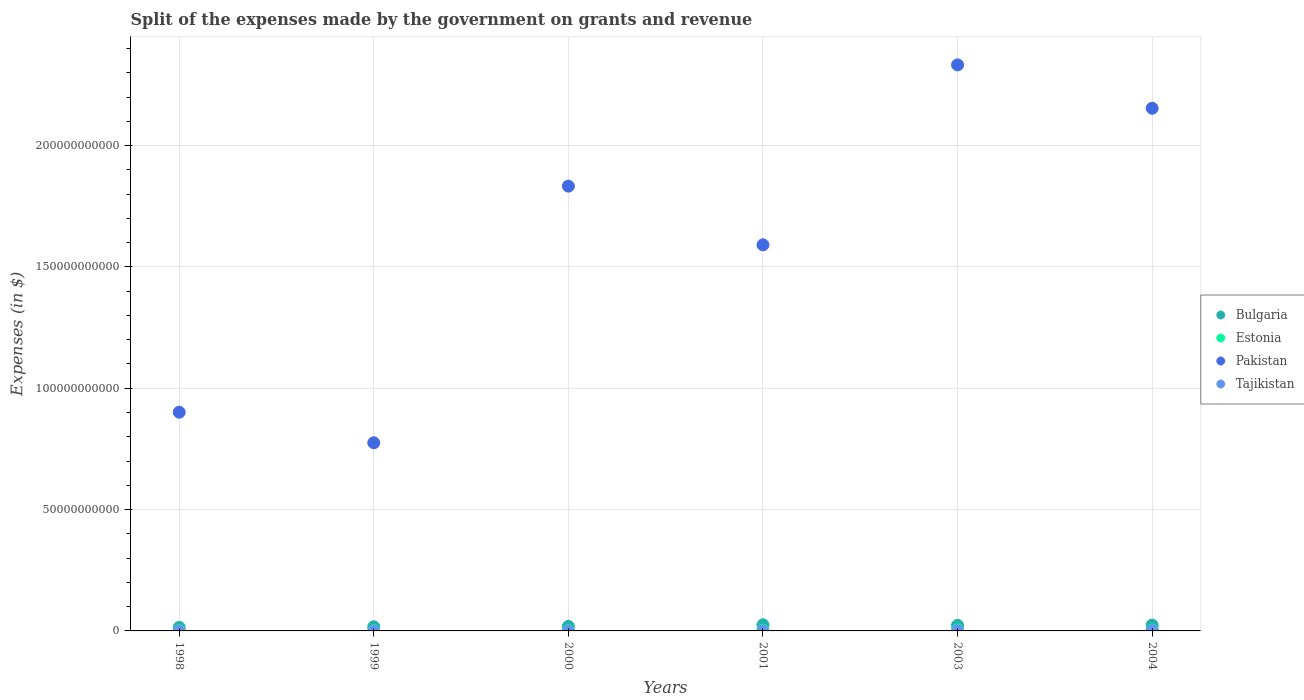How many different coloured dotlines are there?
Offer a terse response. 4. What is the expenses made by the government on grants and revenue in Pakistan in 2000?
Provide a short and direct response. 1.83e+11. Across all years, what is the maximum expenses made by the government on grants and revenue in Bulgaria?
Offer a very short reply. 2.52e+09. Across all years, what is the minimum expenses made by the government on grants and revenue in Tajikistan?
Offer a terse response. 5.25e+06. In which year was the expenses made by the government on grants and revenue in Pakistan maximum?
Offer a very short reply. 2003. What is the total expenses made by the government on grants and revenue in Tajikistan in the graph?
Offer a very short reply. 3.06e+08. What is the difference between the expenses made by the government on grants and revenue in Estonia in 1999 and that in 2000?
Offer a very short reply. -8.25e+07. What is the difference between the expenses made by the government on grants and revenue in Estonia in 1998 and the expenses made by the government on grants and revenue in Bulgaria in 1999?
Keep it short and to the point. -1.52e+09. What is the average expenses made by the government on grants and revenue in Tajikistan per year?
Your response must be concise. 5.10e+07. In the year 2004, what is the difference between the expenses made by the government on grants and revenue in Tajikistan and expenses made by the government on grants and revenue in Pakistan?
Give a very brief answer. -2.15e+11. In how many years, is the expenses made by the government on grants and revenue in Estonia greater than 120000000000 $?
Offer a terse response. 0. What is the ratio of the expenses made by the government on grants and revenue in Pakistan in 1998 to that in 2000?
Offer a very short reply. 0.49. Is the expenses made by the government on grants and revenue in Bulgaria in 2000 less than that in 2001?
Offer a very short reply. Yes. Is the difference between the expenses made by the government on grants and revenue in Tajikistan in 1999 and 2004 greater than the difference between the expenses made by the government on grants and revenue in Pakistan in 1999 and 2004?
Provide a succinct answer. Yes. What is the difference between the highest and the second highest expenses made by the government on grants and revenue in Bulgaria?
Make the answer very short. 1.20e+08. What is the difference between the highest and the lowest expenses made by the government on grants and revenue in Estonia?
Keep it short and to the point. 2.23e+08. In how many years, is the expenses made by the government on grants and revenue in Pakistan greater than the average expenses made by the government on grants and revenue in Pakistan taken over all years?
Make the answer very short. 3. Is the sum of the expenses made by the government on grants and revenue in Estonia in 1999 and 2001 greater than the maximum expenses made by the government on grants and revenue in Bulgaria across all years?
Your response must be concise. No. Is it the case that in every year, the sum of the expenses made by the government on grants and revenue in Tajikistan and expenses made by the government on grants and revenue in Bulgaria  is greater than the sum of expenses made by the government on grants and revenue in Pakistan and expenses made by the government on grants and revenue in Estonia?
Your response must be concise. No. Is it the case that in every year, the sum of the expenses made by the government on grants and revenue in Tajikistan and expenses made by the government on grants and revenue in Bulgaria  is greater than the expenses made by the government on grants and revenue in Estonia?
Provide a short and direct response. Yes. Does the expenses made by the government on grants and revenue in Pakistan monotonically increase over the years?
Keep it short and to the point. No. How many dotlines are there?
Give a very brief answer. 4. Does the graph contain grids?
Provide a short and direct response. Yes. Where does the legend appear in the graph?
Your response must be concise. Center right. What is the title of the graph?
Ensure brevity in your answer.  Split of the expenses made by the government on grants and revenue. Does "South Asia" appear as one of the legend labels in the graph?
Ensure brevity in your answer.  No. What is the label or title of the Y-axis?
Ensure brevity in your answer.  Expenses (in $). What is the Expenses (in $) of Bulgaria in 1998?
Your answer should be very brief. 1.45e+09. What is the Expenses (in $) of Estonia in 1998?
Your response must be concise. 1.80e+08. What is the Expenses (in $) in Pakistan in 1998?
Provide a short and direct response. 9.01e+1. What is the Expenses (in $) in Tajikistan in 1998?
Give a very brief answer. 5.25e+06. What is the Expenses (in $) of Bulgaria in 1999?
Offer a terse response. 1.70e+09. What is the Expenses (in $) of Estonia in 1999?
Your response must be concise. 1.80e+08. What is the Expenses (in $) of Pakistan in 1999?
Offer a very short reply. 7.75e+1. What is the Expenses (in $) of Tajikistan in 1999?
Make the answer very short. 6.30e+06. What is the Expenses (in $) in Bulgaria in 2000?
Provide a short and direct response. 1.86e+09. What is the Expenses (in $) of Estonia in 2000?
Your answer should be very brief. 2.62e+08. What is the Expenses (in $) of Pakistan in 2000?
Provide a short and direct response. 1.83e+11. What is the Expenses (in $) in Tajikistan in 2000?
Provide a succinct answer. 1.41e+07. What is the Expenses (in $) of Bulgaria in 2001?
Provide a short and direct response. 2.52e+09. What is the Expenses (in $) in Estonia in 2001?
Make the answer very short. 2.59e+08. What is the Expenses (in $) in Pakistan in 2001?
Give a very brief answer. 1.59e+11. What is the Expenses (in $) in Tajikistan in 2001?
Provide a short and direct response. 2.53e+07. What is the Expenses (in $) of Bulgaria in 2003?
Provide a short and direct response. 2.30e+09. What is the Expenses (in $) in Estonia in 2003?
Ensure brevity in your answer.  3.90e+08. What is the Expenses (in $) in Pakistan in 2003?
Offer a terse response. 2.33e+11. What is the Expenses (in $) of Tajikistan in 2003?
Provide a short and direct response. 9.93e+07. What is the Expenses (in $) in Bulgaria in 2004?
Give a very brief answer. 2.40e+09. What is the Expenses (in $) in Estonia in 2004?
Offer a terse response. 4.03e+08. What is the Expenses (in $) of Pakistan in 2004?
Keep it short and to the point. 2.15e+11. What is the Expenses (in $) of Tajikistan in 2004?
Offer a terse response. 1.56e+08. Across all years, what is the maximum Expenses (in $) in Bulgaria?
Ensure brevity in your answer.  2.52e+09. Across all years, what is the maximum Expenses (in $) of Estonia?
Provide a succinct answer. 4.03e+08. Across all years, what is the maximum Expenses (in $) in Pakistan?
Make the answer very short. 2.33e+11. Across all years, what is the maximum Expenses (in $) of Tajikistan?
Provide a short and direct response. 1.56e+08. Across all years, what is the minimum Expenses (in $) in Bulgaria?
Offer a terse response. 1.45e+09. Across all years, what is the minimum Expenses (in $) of Estonia?
Your answer should be very brief. 1.80e+08. Across all years, what is the minimum Expenses (in $) in Pakistan?
Offer a terse response. 7.75e+1. Across all years, what is the minimum Expenses (in $) of Tajikistan?
Your response must be concise. 5.25e+06. What is the total Expenses (in $) in Bulgaria in the graph?
Ensure brevity in your answer.  1.22e+1. What is the total Expenses (in $) of Estonia in the graph?
Give a very brief answer. 1.67e+09. What is the total Expenses (in $) of Pakistan in the graph?
Your answer should be compact. 9.59e+11. What is the total Expenses (in $) of Tajikistan in the graph?
Your answer should be compact. 3.06e+08. What is the difference between the Expenses (in $) in Bulgaria in 1998 and that in 1999?
Your answer should be compact. -2.55e+08. What is the difference between the Expenses (in $) of Estonia in 1998 and that in 1999?
Make the answer very short. 6.00e+05. What is the difference between the Expenses (in $) in Pakistan in 1998 and that in 1999?
Offer a terse response. 1.26e+1. What is the difference between the Expenses (in $) of Tajikistan in 1998 and that in 1999?
Your answer should be very brief. -1.05e+06. What is the difference between the Expenses (in $) of Bulgaria in 1998 and that in 2000?
Provide a succinct answer. -4.12e+08. What is the difference between the Expenses (in $) of Estonia in 1998 and that in 2000?
Ensure brevity in your answer.  -8.19e+07. What is the difference between the Expenses (in $) of Pakistan in 1998 and that in 2000?
Offer a terse response. -9.32e+1. What is the difference between the Expenses (in $) of Tajikistan in 1998 and that in 2000?
Provide a succinct answer. -8.87e+06. What is the difference between the Expenses (in $) of Bulgaria in 1998 and that in 2001?
Provide a short and direct response. -1.07e+09. What is the difference between the Expenses (in $) of Estonia in 1998 and that in 2001?
Provide a short and direct response. -7.86e+07. What is the difference between the Expenses (in $) in Pakistan in 1998 and that in 2001?
Offer a terse response. -6.90e+1. What is the difference between the Expenses (in $) of Tajikistan in 1998 and that in 2001?
Provide a short and direct response. -2.00e+07. What is the difference between the Expenses (in $) in Bulgaria in 1998 and that in 2003?
Your answer should be very brief. -8.55e+08. What is the difference between the Expenses (in $) in Estonia in 1998 and that in 2003?
Your response must be concise. -2.10e+08. What is the difference between the Expenses (in $) of Pakistan in 1998 and that in 2003?
Make the answer very short. -1.43e+11. What is the difference between the Expenses (in $) in Tajikistan in 1998 and that in 2003?
Provide a succinct answer. -9.41e+07. What is the difference between the Expenses (in $) in Bulgaria in 1998 and that in 2004?
Ensure brevity in your answer.  -9.47e+08. What is the difference between the Expenses (in $) of Estonia in 1998 and that in 2004?
Give a very brief answer. -2.23e+08. What is the difference between the Expenses (in $) in Pakistan in 1998 and that in 2004?
Your response must be concise. -1.25e+11. What is the difference between the Expenses (in $) in Tajikistan in 1998 and that in 2004?
Keep it short and to the point. -1.51e+08. What is the difference between the Expenses (in $) of Bulgaria in 1999 and that in 2000?
Ensure brevity in your answer.  -1.57e+08. What is the difference between the Expenses (in $) of Estonia in 1999 and that in 2000?
Offer a terse response. -8.25e+07. What is the difference between the Expenses (in $) in Pakistan in 1999 and that in 2000?
Offer a terse response. -1.06e+11. What is the difference between the Expenses (in $) in Tajikistan in 1999 and that in 2000?
Your answer should be compact. -7.82e+06. What is the difference between the Expenses (in $) of Bulgaria in 1999 and that in 2001?
Provide a short and direct response. -8.12e+08. What is the difference between the Expenses (in $) in Estonia in 1999 and that in 2001?
Make the answer very short. -7.92e+07. What is the difference between the Expenses (in $) of Pakistan in 1999 and that in 2001?
Make the answer very short. -8.16e+1. What is the difference between the Expenses (in $) in Tajikistan in 1999 and that in 2001?
Your answer should be very brief. -1.90e+07. What is the difference between the Expenses (in $) of Bulgaria in 1999 and that in 2003?
Keep it short and to the point. -6.00e+08. What is the difference between the Expenses (in $) of Estonia in 1999 and that in 2003?
Your response must be concise. -2.10e+08. What is the difference between the Expenses (in $) of Pakistan in 1999 and that in 2003?
Your response must be concise. -1.56e+11. What is the difference between the Expenses (in $) of Tajikistan in 1999 and that in 2003?
Your response must be concise. -9.30e+07. What is the difference between the Expenses (in $) of Bulgaria in 1999 and that in 2004?
Your answer should be compact. -6.92e+08. What is the difference between the Expenses (in $) of Estonia in 1999 and that in 2004?
Your answer should be very brief. -2.23e+08. What is the difference between the Expenses (in $) in Pakistan in 1999 and that in 2004?
Offer a very short reply. -1.38e+11. What is the difference between the Expenses (in $) of Tajikistan in 1999 and that in 2004?
Your response must be concise. -1.50e+08. What is the difference between the Expenses (in $) of Bulgaria in 2000 and that in 2001?
Provide a short and direct response. -6.55e+08. What is the difference between the Expenses (in $) in Estonia in 2000 and that in 2001?
Make the answer very short. 3.30e+06. What is the difference between the Expenses (in $) of Pakistan in 2000 and that in 2001?
Provide a succinct answer. 2.42e+1. What is the difference between the Expenses (in $) of Tajikistan in 2000 and that in 2001?
Keep it short and to the point. -1.12e+07. What is the difference between the Expenses (in $) in Bulgaria in 2000 and that in 2003?
Your answer should be very brief. -4.43e+08. What is the difference between the Expenses (in $) in Estonia in 2000 and that in 2003?
Ensure brevity in your answer.  -1.28e+08. What is the difference between the Expenses (in $) of Pakistan in 2000 and that in 2003?
Offer a terse response. -5.00e+1. What is the difference between the Expenses (in $) of Tajikistan in 2000 and that in 2003?
Your answer should be compact. -8.52e+07. What is the difference between the Expenses (in $) in Bulgaria in 2000 and that in 2004?
Your answer should be very brief. -5.35e+08. What is the difference between the Expenses (in $) in Estonia in 2000 and that in 2004?
Ensure brevity in your answer.  -1.41e+08. What is the difference between the Expenses (in $) of Pakistan in 2000 and that in 2004?
Ensure brevity in your answer.  -3.21e+1. What is the difference between the Expenses (in $) in Tajikistan in 2000 and that in 2004?
Keep it short and to the point. -1.42e+08. What is the difference between the Expenses (in $) of Bulgaria in 2001 and that in 2003?
Provide a short and direct response. 2.13e+08. What is the difference between the Expenses (in $) in Estonia in 2001 and that in 2003?
Provide a succinct answer. -1.31e+08. What is the difference between the Expenses (in $) in Pakistan in 2001 and that in 2003?
Your answer should be very brief. -7.42e+1. What is the difference between the Expenses (in $) in Tajikistan in 2001 and that in 2003?
Offer a terse response. -7.40e+07. What is the difference between the Expenses (in $) in Bulgaria in 2001 and that in 2004?
Provide a short and direct response. 1.20e+08. What is the difference between the Expenses (in $) of Estonia in 2001 and that in 2004?
Make the answer very short. -1.44e+08. What is the difference between the Expenses (in $) in Pakistan in 2001 and that in 2004?
Your answer should be compact. -5.63e+1. What is the difference between the Expenses (in $) in Tajikistan in 2001 and that in 2004?
Give a very brief answer. -1.31e+08. What is the difference between the Expenses (in $) of Bulgaria in 2003 and that in 2004?
Provide a short and direct response. -9.24e+07. What is the difference between the Expenses (in $) of Estonia in 2003 and that in 2004?
Keep it short and to the point. -1.28e+07. What is the difference between the Expenses (in $) of Pakistan in 2003 and that in 2004?
Offer a terse response. 1.79e+1. What is the difference between the Expenses (in $) of Tajikistan in 2003 and that in 2004?
Offer a very short reply. -5.65e+07. What is the difference between the Expenses (in $) of Bulgaria in 1998 and the Expenses (in $) of Estonia in 1999?
Offer a very short reply. 1.27e+09. What is the difference between the Expenses (in $) of Bulgaria in 1998 and the Expenses (in $) of Pakistan in 1999?
Keep it short and to the point. -7.61e+1. What is the difference between the Expenses (in $) of Bulgaria in 1998 and the Expenses (in $) of Tajikistan in 1999?
Provide a short and direct response. 1.44e+09. What is the difference between the Expenses (in $) of Estonia in 1998 and the Expenses (in $) of Pakistan in 1999?
Provide a short and direct response. -7.73e+1. What is the difference between the Expenses (in $) in Estonia in 1998 and the Expenses (in $) in Tajikistan in 1999?
Make the answer very short. 1.74e+08. What is the difference between the Expenses (in $) in Pakistan in 1998 and the Expenses (in $) in Tajikistan in 1999?
Your answer should be compact. 9.01e+1. What is the difference between the Expenses (in $) in Bulgaria in 1998 and the Expenses (in $) in Estonia in 2000?
Offer a terse response. 1.19e+09. What is the difference between the Expenses (in $) of Bulgaria in 1998 and the Expenses (in $) of Pakistan in 2000?
Offer a very short reply. -1.82e+11. What is the difference between the Expenses (in $) of Bulgaria in 1998 and the Expenses (in $) of Tajikistan in 2000?
Offer a terse response. 1.43e+09. What is the difference between the Expenses (in $) in Estonia in 1998 and the Expenses (in $) in Pakistan in 2000?
Offer a terse response. -1.83e+11. What is the difference between the Expenses (in $) of Estonia in 1998 and the Expenses (in $) of Tajikistan in 2000?
Your answer should be compact. 1.66e+08. What is the difference between the Expenses (in $) of Pakistan in 1998 and the Expenses (in $) of Tajikistan in 2000?
Make the answer very short. 9.01e+1. What is the difference between the Expenses (in $) of Bulgaria in 1998 and the Expenses (in $) of Estonia in 2001?
Keep it short and to the point. 1.19e+09. What is the difference between the Expenses (in $) of Bulgaria in 1998 and the Expenses (in $) of Pakistan in 2001?
Provide a short and direct response. -1.58e+11. What is the difference between the Expenses (in $) of Bulgaria in 1998 and the Expenses (in $) of Tajikistan in 2001?
Ensure brevity in your answer.  1.42e+09. What is the difference between the Expenses (in $) of Estonia in 1998 and the Expenses (in $) of Pakistan in 2001?
Your answer should be compact. -1.59e+11. What is the difference between the Expenses (in $) in Estonia in 1998 and the Expenses (in $) in Tajikistan in 2001?
Keep it short and to the point. 1.55e+08. What is the difference between the Expenses (in $) of Pakistan in 1998 and the Expenses (in $) of Tajikistan in 2001?
Keep it short and to the point. 9.01e+1. What is the difference between the Expenses (in $) of Bulgaria in 1998 and the Expenses (in $) of Estonia in 2003?
Your answer should be very brief. 1.06e+09. What is the difference between the Expenses (in $) in Bulgaria in 1998 and the Expenses (in $) in Pakistan in 2003?
Your response must be concise. -2.32e+11. What is the difference between the Expenses (in $) in Bulgaria in 1998 and the Expenses (in $) in Tajikistan in 2003?
Make the answer very short. 1.35e+09. What is the difference between the Expenses (in $) of Estonia in 1998 and the Expenses (in $) of Pakistan in 2003?
Your answer should be compact. -2.33e+11. What is the difference between the Expenses (in $) in Estonia in 1998 and the Expenses (in $) in Tajikistan in 2003?
Your response must be concise. 8.08e+07. What is the difference between the Expenses (in $) of Pakistan in 1998 and the Expenses (in $) of Tajikistan in 2003?
Provide a short and direct response. 9.00e+1. What is the difference between the Expenses (in $) in Bulgaria in 1998 and the Expenses (in $) in Estonia in 2004?
Give a very brief answer. 1.05e+09. What is the difference between the Expenses (in $) in Bulgaria in 1998 and the Expenses (in $) in Pakistan in 2004?
Keep it short and to the point. -2.14e+11. What is the difference between the Expenses (in $) of Bulgaria in 1998 and the Expenses (in $) of Tajikistan in 2004?
Your answer should be very brief. 1.29e+09. What is the difference between the Expenses (in $) in Estonia in 1998 and the Expenses (in $) in Pakistan in 2004?
Offer a very short reply. -2.15e+11. What is the difference between the Expenses (in $) in Estonia in 1998 and the Expenses (in $) in Tajikistan in 2004?
Give a very brief answer. 2.42e+07. What is the difference between the Expenses (in $) in Pakistan in 1998 and the Expenses (in $) in Tajikistan in 2004?
Provide a short and direct response. 9.00e+1. What is the difference between the Expenses (in $) of Bulgaria in 1999 and the Expenses (in $) of Estonia in 2000?
Keep it short and to the point. 1.44e+09. What is the difference between the Expenses (in $) in Bulgaria in 1999 and the Expenses (in $) in Pakistan in 2000?
Provide a succinct answer. -1.82e+11. What is the difference between the Expenses (in $) in Bulgaria in 1999 and the Expenses (in $) in Tajikistan in 2000?
Your answer should be compact. 1.69e+09. What is the difference between the Expenses (in $) of Estonia in 1999 and the Expenses (in $) of Pakistan in 2000?
Offer a terse response. -1.83e+11. What is the difference between the Expenses (in $) in Estonia in 1999 and the Expenses (in $) in Tajikistan in 2000?
Provide a short and direct response. 1.65e+08. What is the difference between the Expenses (in $) of Pakistan in 1999 and the Expenses (in $) of Tajikistan in 2000?
Your response must be concise. 7.75e+1. What is the difference between the Expenses (in $) in Bulgaria in 1999 and the Expenses (in $) in Estonia in 2001?
Offer a very short reply. 1.44e+09. What is the difference between the Expenses (in $) of Bulgaria in 1999 and the Expenses (in $) of Pakistan in 2001?
Provide a succinct answer. -1.57e+11. What is the difference between the Expenses (in $) in Bulgaria in 1999 and the Expenses (in $) in Tajikistan in 2001?
Provide a succinct answer. 1.68e+09. What is the difference between the Expenses (in $) in Estonia in 1999 and the Expenses (in $) in Pakistan in 2001?
Ensure brevity in your answer.  -1.59e+11. What is the difference between the Expenses (in $) of Estonia in 1999 and the Expenses (in $) of Tajikistan in 2001?
Your answer should be compact. 1.54e+08. What is the difference between the Expenses (in $) of Pakistan in 1999 and the Expenses (in $) of Tajikistan in 2001?
Your response must be concise. 7.75e+1. What is the difference between the Expenses (in $) in Bulgaria in 1999 and the Expenses (in $) in Estonia in 2003?
Ensure brevity in your answer.  1.31e+09. What is the difference between the Expenses (in $) in Bulgaria in 1999 and the Expenses (in $) in Pakistan in 2003?
Offer a terse response. -2.32e+11. What is the difference between the Expenses (in $) in Bulgaria in 1999 and the Expenses (in $) in Tajikistan in 2003?
Make the answer very short. 1.60e+09. What is the difference between the Expenses (in $) of Estonia in 1999 and the Expenses (in $) of Pakistan in 2003?
Offer a very short reply. -2.33e+11. What is the difference between the Expenses (in $) in Estonia in 1999 and the Expenses (in $) in Tajikistan in 2003?
Keep it short and to the point. 8.02e+07. What is the difference between the Expenses (in $) in Pakistan in 1999 and the Expenses (in $) in Tajikistan in 2003?
Offer a terse response. 7.74e+1. What is the difference between the Expenses (in $) of Bulgaria in 1999 and the Expenses (in $) of Estonia in 2004?
Offer a very short reply. 1.30e+09. What is the difference between the Expenses (in $) of Bulgaria in 1999 and the Expenses (in $) of Pakistan in 2004?
Your answer should be compact. -2.14e+11. What is the difference between the Expenses (in $) in Bulgaria in 1999 and the Expenses (in $) in Tajikistan in 2004?
Give a very brief answer. 1.55e+09. What is the difference between the Expenses (in $) in Estonia in 1999 and the Expenses (in $) in Pakistan in 2004?
Your answer should be very brief. -2.15e+11. What is the difference between the Expenses (in $) in Estonia in 1999 and the Expenses (in $) in Tajikistan in 2004?
Give a very brief answer. 2.36e+07. What is the difference between the Expenses (in $) in Pakistan in 1999 and the Expenses (in $) in Tajikistan in 2004?
Your answer should be very brief. 7.74e+1. What is the difference between the Expenses (in $) of Bulgaria in 2000 and the Expenses (in $) of Estonia in 2001?
Offer a terse response. 1.60e+09. What is the difference between the Expenses (in $) of Bulgaria in 2000 and the Expenses (in $) of Pakistan in 2001?
Your answer should be compact. -1.57e+11. What is the difference between the Expenses (in $) of Bulgaria in 2000 and the Expenses (in $) of Tajikistan in 2001?
Provide a short and direct response. 1.84e+09. What is the difference between the Expenses (in $) of Estonia in 2000 and the Expenses (in $) of Pakistan in 2001?
Your answer should be compact. -1.59e+11. What is the difference between the Expenses (in $) in Estonia in 2000 and the Expenses (in $) in Tajikistan in 2001?
Provide a short and direct response. 2.37e+08. What is the difference between the Expenses (in $) in Pakistan in 2000 and the Expenses (in $) in Tajikistan in 2001?
Provide a succinct answer. 1.83e+11. What is the difference between the Expenses (in $) in Bulgaria in 2000 and the Expenses (in $) in Estonia in 2003?
Provide a succinct answer. 1.47e+09. What is the difference between the Expenses (in $) in Bulgaria in 2000 and the Expenses (in $) in Pakistan in 2003?
Offer a very short reply. -2.31e+11. What is the difference between the Expenses (in $) of Bulgaria in 2000 and the Expenses (in $) of Tajikistan in 2003?
Offer a very short reply. 1.76e+09. What is the difference between the Expenses (in $) in Estonia in 2000 and the Expenses (in $) in Pakistan in 2003?
Offer a very short reply. -2.33e+11. What is the difference between the Expenses (in $) in Estonia in 2000 and the Expenses (in $) in Tajikistan in 2003?
Keep it short and to the point. 1.63e+08. What is the difference between the Expenses (in $) of Pakistan in 2000 and the Expenses (in $) of Tajikistan in 2003?
Offer a terse response. 1.83e+11. What is the difference between the Expenses (in $) in Bulgaria in 2000 and the Expenses (in $) in Estonia in 2004?
Offer a terse response. 1.46e+09. What is the difference between the Expenses (in $) of Bulgaria in 2000 and the Expenses (in $) of Pakistan in 2004?
Offer a very short reply. -2.13e+11. What is the difference between the Expenses (in $) in Bulgaria in 2000 and the Expenses (in $) in Tajikistan in 2004?
Give a very brief answer. 1.70e+09. What is the difference between the Expenses (in $) of Estonia in 2000 and the Expenses (in $) of Pakistan in 2004?
Provide a short and direct response. -2.15e+11. What is the difference between the Expenses (in $) of Estonia in 2000 and the Expenses (in $) of Tajikistan in 2004?
Your response must be concise. 1.06e+08. What is the difference between the Expenses (in $) in Pakistan in 2000 and the Expenses (in $) in Tajikistan in 2004?
Your answer should be very brief. 1.83e+11. What is the difference between the Expenses (in $) of Bulgaria in 2001 and the Expenses (in $) of Estonia in 2003?
Make the answer very short. 2.13e+09. What is the difference between the Expenses (in $) of Bulgaria in 2001 and the Expenses (in $) of Pakistan in 2003?
Give a very brief answer. -2.31e+11. What is the difference between the Expenses (in $) of Bulgaria in 2001 and the Expenses (in $) of Tajikistan in 2003?
Provide a succinct answer. 2.42e+09. What is the difference between the Expenses (in $) in Estonia in 2001 and the Expenses (in $) in Pakistan in 2003?
Your response must be concise. -2.33e+11. What is the difference between the Expenses (in $) in Estonia in 2001 and the Expenses (in $) in Tajikistan in 2003?
Your answer should be very brief. 1.59e+08. What is the difference between the Expenses (in $) in Pakistan in 2001 and the Expenses (in $) in Tajikistan in 2003?
Keep it short and to the point. 1.59e+11. What is the difference between the Expenses (in $) in Bulgaria in 2001 and the Expenses (in $) in Estonia in 2004?
Provide a short and direct response. 2.11e+09. What is the difference between the Expenses (in $) of Bulgaria in 2001 and the Expenses (in $) of Pakistan in 2004?
Provide a succinct answer. -2.13e+11. What is the difference between the Expenses (in $) of Bulgaria in 2001 and the Expenses (in $) of Tajikistan in 2004?
Offer a very short reply. 2.36e+09. What is the difference between the Expenses (in $) in Estonia in 2001 and the Expenses (in $) in Pakistan in 2004?
Provide a short and direct response. -2.15e+11. What is the difference between the Expenses (in $) of Estonia in 2001 and the Expenses (in $) of Tajikistan in 2004?
Keep it short and to the point. 1.03e+08. What is the difference between the Expenses (in $) of Pakistan in 2001 and the Expenses (in $) of Tajikistan in 2004?
Make the answer very short. 1.59e+11. What is the difference between the Expenses (in $) in Bulgaria in 2003 and the Expenses (in $) in Estonia in 2004?
Provide a succinct answer. 1.90e+09. What is the difference between the Expenses (in $) of Bulgaria in 2003 and the Expenses (in $) of Pakistan in 2004?
Provide a succinct answer. -2.13e+11. What is the difference between the Expenses (in $) in Bulgaria in 2003 and the Expenses (in $) in Tajikistan in 2004?
Make the answer very short. 2.15e+09. What is the difference between the Expenses (in $) in Estonia in 2003 and the Expenses (in $) in Pakistan in 2004?
Provide a succinct answer. -2.15e+11. What is the difference between the Expenses (in $) of Estonia in 2003 and the Expenses (in $) of Tajikistan in 2004?
Your response must be concise. 2.34e+08. What is the difference between the Expenses (in $) in Pakistan in 2003 and the Expenses (in $) in Tajikistan in 2004?
Give a very brief answer. 2.33e+11. What is the average Expenses (in $) in Bulgaria per year?
Ensure brevity in your answer.  2.04e+09. What is the average Expenses (in $) in Estonia per year?
Provide a short and direct response. 2.79e+08. What is the average Expenses (in $) in Pakistan per year?
Offer a terse response. 1.60e+11. What is the average Expenses (in $) of Tajikistan per year?
Your answer should be compact. 5.10e+07. In the year 1998, what is the difference between the Expenses (in $) of Bulgaria and Expenses (in $) of Estonia?
Provide a succinct answer. 1.27e+09. In the year 1998, what is the difference between the Expenses (in $) in Bulgaria and Expenses (in $) in Pakistan?
Provide a short and direct response. -8.87e+1. In the year 1998, what is the difference between the Expenses (in $) of Bulgaria and Expenses (in $) of Tajikistan?
Your answer should be compact. 1.44e+09. In the year 1998, what is the difference between the Expenses (in $) in Estonia and Expenses (in $) in Pakistan?
Your answer should be compact. -8.99e+1. In the year 1998, what is the difference between the Expenses (in $) in Estonia and Expenses (in $) in Tajikistan?
Ensure brevity in your answer.  1.75e+08. In the year 1998, what is the difference between the Expenses (in $) in Pakistan and Expenses (in $) in Tajikistan?
Your response must be concise. 9.01e+1. In the year 1999, what is the difference between the Expenses (in $) of Bulgaria and Expenses (in $) of Estonia?
Keep it short and to the point. 1.52e+09. In the year 1999, what is the difference between the Expenses (in $) in Bulgaria and Expenses (in $) in Pakistan?
Your answer should be very brief. -7.58e+1. In the year 1999, what is the difference between the Expenses (in $) of Bulgaria and Expenses (in $) of Tajikistan?
Your response must be concise. 1.70e+09. In the year 1999, what is the difference between the Expenses (in $) in Estonia and Expenses (in $) in Pakistan?
Ensure brevity in your answer.  -7.73e+1. In the year 1999, what is the difference between the Expenses (in $) in Estonia and Expenses (in $) in Tajikistan?
Give a very brief answer. 1.73e+08. In the year 1999, what is the difference between the Expenses (in $) in Pakistan and Expenses (in $) in Tajikistan?
Keep it short and to the point. 7.75e+1. In the year 2000, what is the difference between the Expenses (in $) in Bulgaria and Expenses (in $) in Estonia?
Provide a short and direct response. 1.60e+09. In the year 2000, what is the difference between the Expenses (in $) in Bulgaria and Expenses (in $) in Pakistan?
Keep it short and to the point. -1.81e+11. In the year 2000, what is the difference between the Expenses (in $) in Bulgaria and Expenses (in $) in Tajikistan?
Offer a very short reply. 1.85e+09. In the year 2000, what is the difference between the Expenses (in $) in Estonia and Expenses (in $) in Pakistan?
Offer a terse response. -1.83e+11. In the year 2000, what is the difference between the Expenses (in $) in Estonia and Expenses (in $) in Tajikistan?
Ensure brevity in your answer.  2.48e+08. In the year 2000, what is the difference between the Expenses (in $) of Pakistan and Expenses (in $) of Tajikistan?
Offer a very short reply. 1.83e+11. In the year 2001, what is the difference between the Expenses (in $) in Bulgaria and Expenses (in $) in Estonia?
Your answer should be compact. 2.26e+09. In the year 2001, what is the difference between the Expenses (in $) in Bulgaria and Expenses (in $) in Pakistan?
Your answer should be compact. -1.57e+11. In the year 2001, what is the difference between the Expenses (in $) of Bulgaria and Expenses (in $) of Tajikistan?
Provide a short and direct response. 2.49e+09. In the year 2001, what is the difference between the Expenses (in $) of Estonia and Expenses (in $) of Pakistan?
Your answer should be compact. -1.59e+11. In the year 2001, what is the difference between the Expenses (in $) of Estonia and Expenses (in $) of Tajikistan?
Offer a terse response. 2.33e+08. In the year 2001, what is the difference between the Expenses (in $) in Pakistan and Expenses (in $) in Tajikistan?
Offer a terse response. 1.59e+11. In the year 2003, what is the difference between the Expenses (in $) of Bulgaria and Expenses (in $) of Estonia?
Offer a terse response. 1.91e+09. In the year 2003, what is the difference between the Expenses (in $) in Bulgaria and Expenses (in $) in Pakistan?
Give a very brief answer. -2.31e+11. In the year 2003, what is the difference between the Expenses (in $) of Bulgaria and Expenses (in $) of Tajikistan?
Give a very brief answer. 2.20e+09. In the year 2003, what is the difference between the Expenses (in $) in Estonia and Expenses (in $) in Pakistan?
Your response must be concise. -2.33e+11. In the year 2003, what is the difference between the Expenses (in $) of Estonia and Expenses (in $) of Tajikistan?
Ensure brevity in your answer.  2.91e+08. In the year 2003, what is the difference between the Expenses (in $) of Pakistan and Expenses (in $) of Tajikistan?
Provide a succinct answer. 2.33e+11. In the year 2004, what is the difference between the Expenses (in $) of Bulgaria and Expenses (in $) of Estonia?
Your response must be concise. 1.99e+09. In the year 2004, what is the difference between the Expenses (in $) of Bulgaria and Expenses (in $) of Pakistan?
Offer a very short reply. -2.13e+11. In the year 2004, what is the difference between the Expenses (in $) in Bulgaria and Expenses (in $) in Tajikistan?
Your answer should be very brief. 2.24e+09. In the year 2004, what is the difference between the Expenses (in $) in Estonia and Expenses (in $) in Pakistan?
Make the answer very short. -2.15e+11. In the year 2004, what is the difference between the Expenses (in $) of Estonia and Expenses (in $) of Tajikistan?
Provide a short and direct response. 2.47e+08. In the year 2004, what is the difference between the Expenses (in $) in Pakistan and Expenses (in $) in Tajikistan?
Offer a terse response. 2.15e+11. What is the ratio of the Expenses (in $) in Bulgaria in 1998 to that in 1999?
Offer a very short reply. 0.85. What is the ratio of the Expenses (in $) in Pakistan in 1998 to that in 1999?
Your answer should be compact. 1.16. What is the ratio of the Expenses (in $) of Tajikistan in 1998 to that in 1999?
Make the answer very short. 0.83. What is the ratio of the Expenses (in $) in Bulgaria in 1998 to that in 2000?
Your answer should be compact. 0.78. What is the ratio of the Expenses (in $) in Estonia in 1998 to that in 2000?
Provide a short and direct response. 0.69. What is the ratio of the Expenses (in $) of Pakistan in 1998 to that in 2000?
Ensure brevity in your answer.  0.49. What is the ratio of the Expenses (in $) of Tajikistan in 1998 to that in 2000?
Your answer should be compact. 0.37. What is the ratio of the Expenses (in $) of Bulgaria in 1998 to that in 2001?
Offer a very short reply. 0.58. What is the ratio of the Expenses (in $) of Estonia in 1998 to that in 2001?
Offer a very short reply. 0.7. What is the ratio of the Expenses (in $) of Pakistan in 1998 to that in 2001?
Give a very brief answer. 0.57. What is the ratio of the Expenses (in $) of Tajikistan in 1998 to that in 2001?
Your answer should be compact. 0.21. What is the ratio of the Expenses (in $) of Bulgaria in 1998 to that in 2003?
Offer a terse response. 0.63. What is the ratio of the Expenses (in $) of Estonia in 1998 to that in 2003?
Ensure brevity in your answer.  0.46. What is the ratio of the Expenses (in $) in Pakistan in 1998 to that in 2003?
Provide a succinct answer. 0.39. What is the ratio of the Expenses (in $) of Tajikistan in 1998 to that in 2003?
Your answer should be very brief. 0.05. What is the ratio of the Expenses (in $) of Bulgaria in 1998 to that in 2004?
Ensure brevity in your answer.  0.6. What is the ratio of the Expenses (in $) in Estonia in 1998 to that in 2004?
Provide a succinct answer. 0.45. What is the ratio of the Expenses (in $) in Pakistan in 1998 to that in 2004?
Give a very brief answer. 0.42. What is the ratio of the Expenses (in $) in Tajikistan in 1998 to that in 2004?
Give a very brief answer. 0.03. What is the ratio of the Expenses (in $) of Bulgaria in 1999 to that in 2000?
Keep it short and to the point. 0.92. What is the ratio of the Expenses (in $) of Estonia in 1999 to that in 2000?
Your response must be concise. 0.69. What is the ratio of the Expenses (in $) of Pakistan in 1999 to that in 2000?
Make the answer very short. 0.42. What is the ratio of the Expenses (in $) in Tajikistan in 1999 to that in 2000?
Keep it short and to the point. 0.45. What is the ratio of the Expenses (in $) in Bulgaria in 1999 to that in 2001?
Make the answer very short. 0.68. What is the ratio of the Expenses (in $) in Estonia in 1999 to that in 2001?
Offer a very short reply. 0.69. What is the ratio of the Expenses (in $) of Pakistan in 1999 to that in 2001?
Your answer should be very brief. 0.49. What is the ratio of the Expenses (in $) of Tajikistan in 1999 to that in 2001?
Provide a succinct answer. 0.25. What is the ratio of the Expenses (in $) in Bulgaria in 1999 to that in 2003?
Your answer should be very brief. 0.74. What is the ratio of the Expenses (in $) in Estonia in 1999 to that in 2003?
Make the answer very short. 0.46. What is the ratio of the Expenses (in $) in Pakistan in 1999 to that in 2003?
Offer a very short reply. 0.33. What is the ratio of the Expenses (in $) of Tajikistan in 1999 to that in 2003?
Your answer should be very brief. 0.06. What is the ratio of the Expenses (in $) in Bulgaria in 1999 to that in 2004?
Your answer should be compact. 0.71. What is the ratio of the Expenses (in $) of Estonia in 1999 to that in 2004?
Your answer should be compact. 0.45. What is the ratio of the Expenses (in $) of Pakistan in 1999 to that in 2004?
Offer a very short reply. 0.36. What is the ratio of the Expenses (in $) of Tajikistan in 1999 to that in 2004?
Your answer should be compact. 0.04. What is the ratio of the Expenses (in $) in Bulgaria in 2000 to that in 2001?
Your response must be concise. 0.74. What is the ratio of the Expenses (in $) of Estonia in 2000 to that in 2001?
Give a very brief answer. 1.01. What is the ratio of the Expenses (in $) of Pakistan in 2000 to that in 2001?
Your answer should be compact. 1.15. What is the ratio of the Expenses (in $) in Tajikistan in 2000 to that in 2001?
Provide a succinct answer. 0.56. What is the ratio of the Expenses (in $) of Bulgaria in 2000 to that in 2003?
Keep it short and to the point. 0.81. What is the ratio of the Expenses (in $) in Estonia in 2000 to that in 2003?
Your answer should be very brief. 0.67. What is the ratio of the Expenses (in $) of Pakistan in 2000 to that in 2003?
Make the answer very short. 0.79. What is the ratio of the Expenses (in $) in Tajikistan in 2000 to that in 2003?
Your response must be concise. 0.14. What is the ratio of the Expenses (in $) of Bulgaria in 2000 to that in 2004?
Your answer should be compact. 0.78. What is the ratio of the Expenses (in $) of Estonia in 2000 to that in 2004?
Provide a short and direct response. 0.65. What is the ratio of the Expenses (in $) of Pakistan in 2000 to that in 2004?
Offer a terse response. 0.85. What is the ratio of the Expenses (in $) of Tajikistan in 2000 to that in 2004?
Your answer should be compact. 0.09. What is the ratio of the Expenses (in $) in Bulgaria in 2001 to that in 2003?
Your answer should be compact. 1.09. What is the ratio of the Expenses (in $) of Estonia in 2001 to that in 2003?
Your response must be concise. 0.66. What is the ratio of the Expenses (in $) in Pakistan in 2001 to that in 2003?
Offer a very short reply. 0.68. What is the ratio of the Expenses (in $) in Tajikistan in 2001 to that in 2003?
Offer a terse response. 0.25. What is the ratio of the Expenses (in $) in Bulgaria in 2001 to that in 2004?
Keep it short and to the point. 1.05. What is the ratio of the Expenses (in $) of Estonia in 2001 to that in 2004?
Keep it short and to the point. 0.64. What is the ratio of the Expenses (in $) in Pakistan in 2001 to that in 2004?
Provide a short and direct response. 0.74. What is the ratio of the Expenses (in $) in Tajikistan in 2001 to that in 2004?
Give a very brief answer. 0.16. What is the ratio of the Expenses (in $) of Bulgaria in 2003 to that in 2004?
Offer a very short reply. 0.96. What is the ratio of the Expenses (in $) of Estonia in 2003 to that in 2004?
Make the answer very short. 0.97. What is the ratio of the Expenses (in $) of Pakistan in 2003 to that in 2004?
Provide a succinct answer. 1.08. What is the ratio of the Expenses (in $) in Tajikistan in 2003 to that in 2004?
Your answer should be compact. 0.64. What is the difference between the highest and the second highest Expenses (in $) of Bulgaria?
Give a very brief answer. 1.20e+08. What is the difference between the highest and the second highest Expenses (in $) in Estonia?
Your answer should be compact. 1.28e+07. What is the difference between the highest and the second highest Expenses (in $) of Pakistan?
Your answer should be very brief. 1.79e+1. What is the difference between the highest and the second highest Expenses (in $) of Tajikistan?
Your answer should be very brief. 5.65e+07. What is the difference between the highest and the lowest Expenses (in $) of Bulgaria?
Your answer should be very brief. 1.07e+09. What is the difference between the highest and the lowest Expenses (in $) in Estonia?
Your response must be concise. 2.23e+08. What is the difference between the highest and the lowest Expenses (in $) in Pakistan?
Your answer should be very brief. 1.56e+11. What is the difference between the highest and the lowest Expenses (in $) in Tajikistan?
Provide a short and direct response. 1.51e+08. 